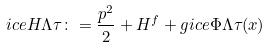Convert formula to latex. <formula><loc_0><loc_0><loc_500><loc_500>\sl i c e { H } { \Lambda } { \tau } \colon = \frac { p ^ { 2 } } { 2 } + H ^ { f } + g \sl i c e { \Phi } { \Lambda } { \tau } ( x )</formula> 